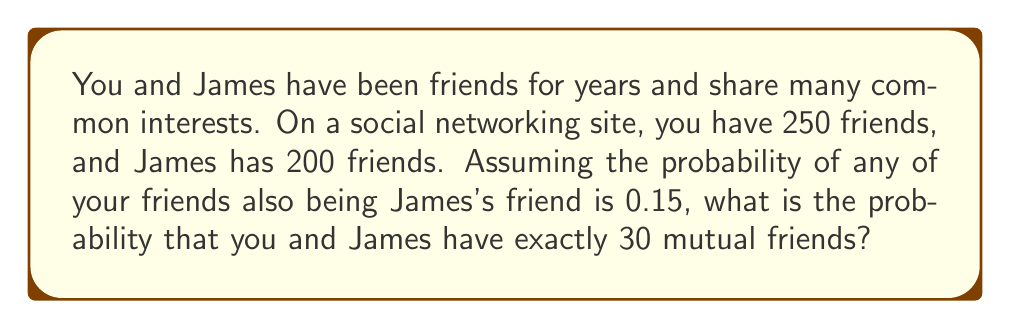Could you help me with this problem? Let's approach this step-by-step using the binomial distribution:

1) Let X be the random variable representing the number of mutual friends.

2) We can model this situation using a binomial distribution because:
   - Each of your friends either is or isn't friends with James (two outcomes).
   - The probability of each friend being mutual is constant (0.15).
   - We assume the friendships are independent.

3) The parameters for the binomial distribution are:
   n = 250 (total number of your friends)
   p = 0.15 (probability of a friend being mutual)

4) We want to find P(X = 30), which is given by the probability mass function of the binomial distribution:

   $$P(X = k) = \binom{n}{k} p^k (1-p)^{n-k}$$

5) Substituting our values:

   $$P(X = 30) = \binom{250}{30} (0.15)^{30} (1-0.15)^{250-30}$$

6) Calculating this:
   
   $$P(X = 30) = \binom{250}{30} (0.15)^{30} (0.85)^{220}$$
   
   $$\approx 0.0815$$

7) Therefore, the probability of having exactly 30 mutual friends with James is approximately 0.0815 or 8.15%.
Answer: 0.0815 